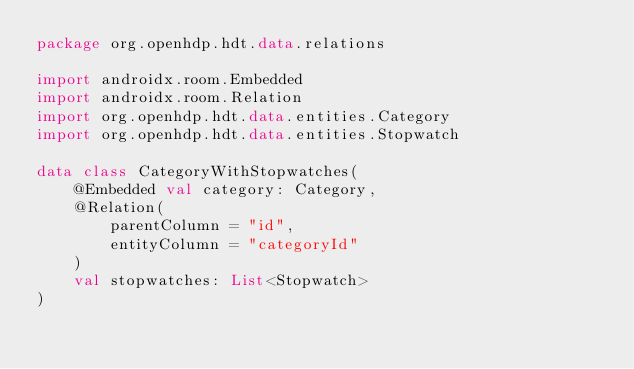Convert code to text. <code><loc_0><loc_0><loc_500><loc_500><_Kotlin_>package org.openhdp.hdt.data.relations

import androidx.room.Embedded
import androidx.room.Relation
import org.openhdp.hdt.data.entities.Category
import org.openhdp.hdt.data.entities.Stopwatch

data class CategoryWithStopwatches(
    @Embedded val category: Category,
    @Relation(
        parentColumn = "id",
        entityColumn = "categoryId"
    )
    val stopwatches: List<Stopwatch>
)</code> 